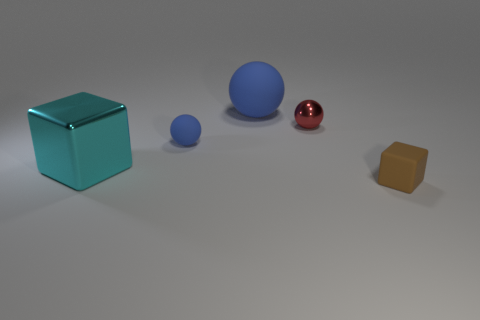Add 3 tiny brown matte cubes. How many objects exist? 8 Subtract all balls. How many objects are left? 2 Subtract all large red cubes. Subtract all small brown matte cubes. How many objects are left? 4 Add 1 blue matte balls. How many blue matte balls are left? 3 Add 5 metallic spheres. How many metallic spheres exist? 6 Subtract 0 purple blocks. How many objects are left? 5 